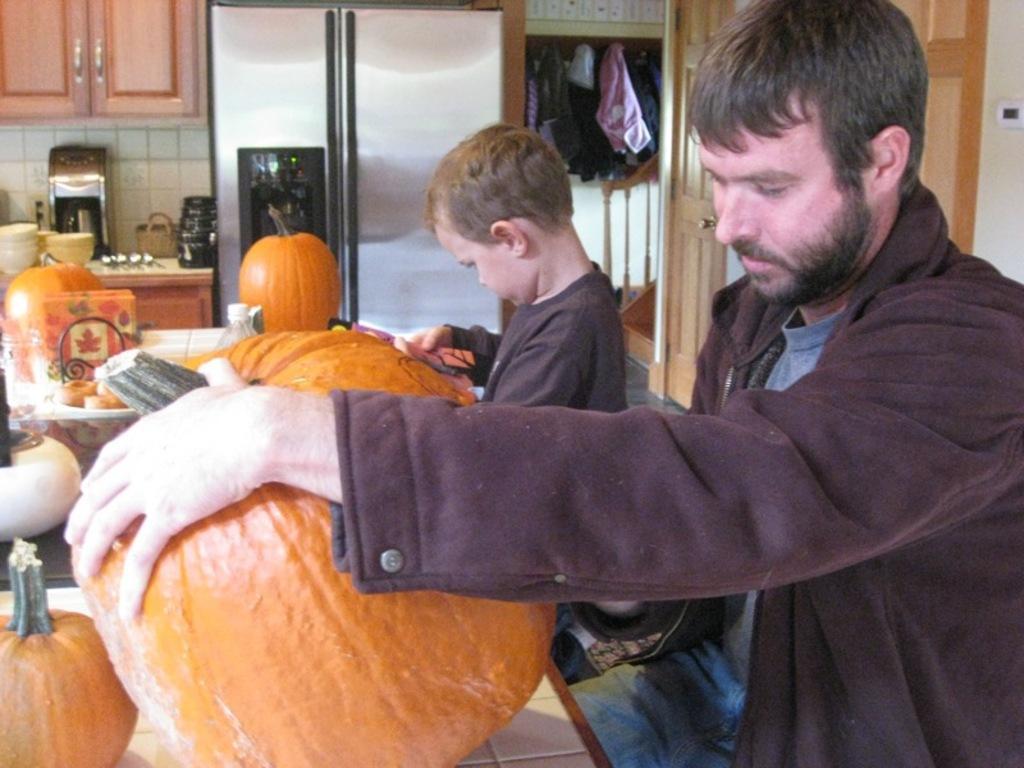In one or two sentences, can you explain what this image depicts? In the image in the center we can see two persons were holding pumpkins. In the background there is a wall,fridge,door,table,basket,machine,bowls,cupboards,clothes,utensils and few other objects. 